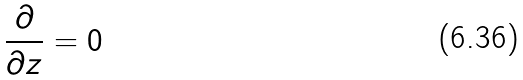Convert formula to latex. <formula><loc_0><loc_0><loc_500><loc_500>\frac { \partial } { \partial z } = 0</formula> 